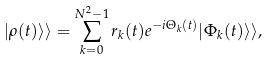Convert formula to latex. <formula><loc_0><loc_0><loc_500><loc_500>| \rho ( t ) \rangle \rangle = \sum _ { k = 0 } ^ { N ^ { 2 } - 1 } r _ { k } ( t ) e ^ { - i \Theta _ { k } ( t ) } | \Phi _ { k } ( t ) \rangle \rangle ,</formula> 